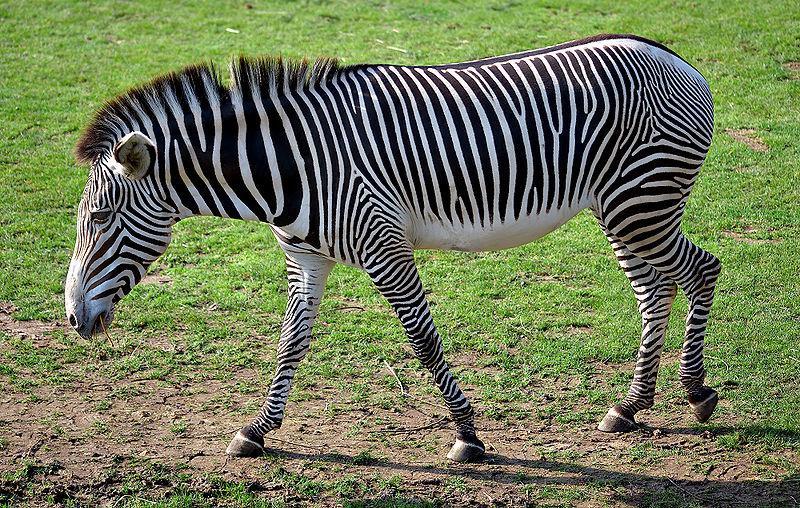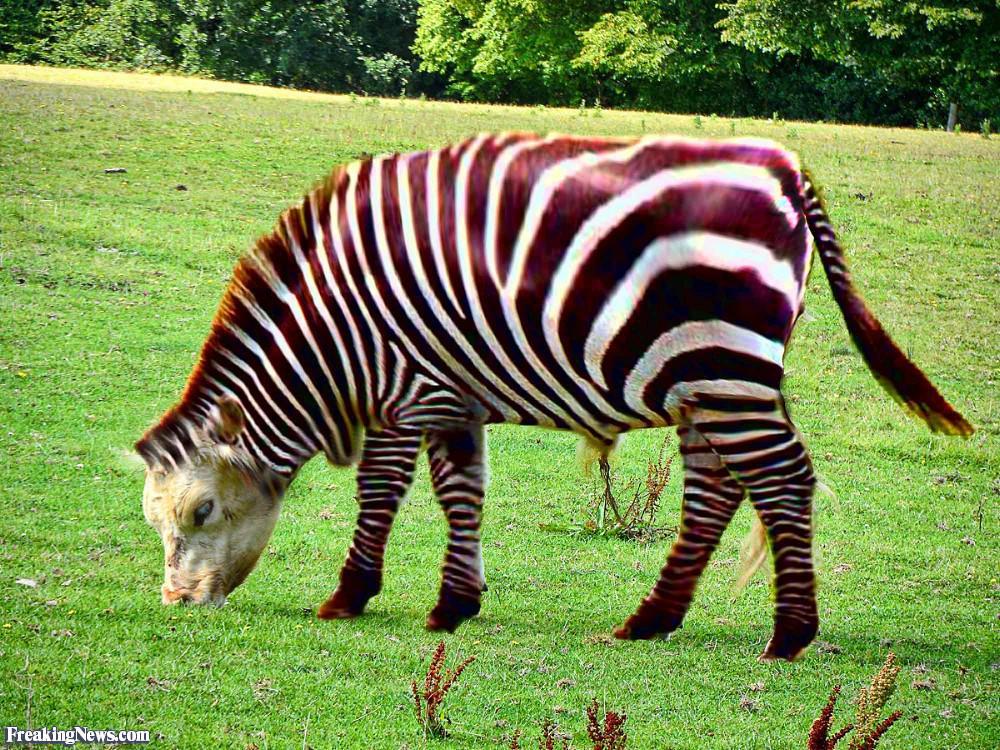The first image is the image on the left, the second image is the image on the right. Considering the images on both sides, is "The left image shows exactly two zebras while the right image shows exactly one." valid? Answer yes or no. No. The first image is the image on the left, the second image is the image on the right. Assess this claim about the two images: "The images contain a total of three zebras.". Correct or not? Answer yes or no. No. 